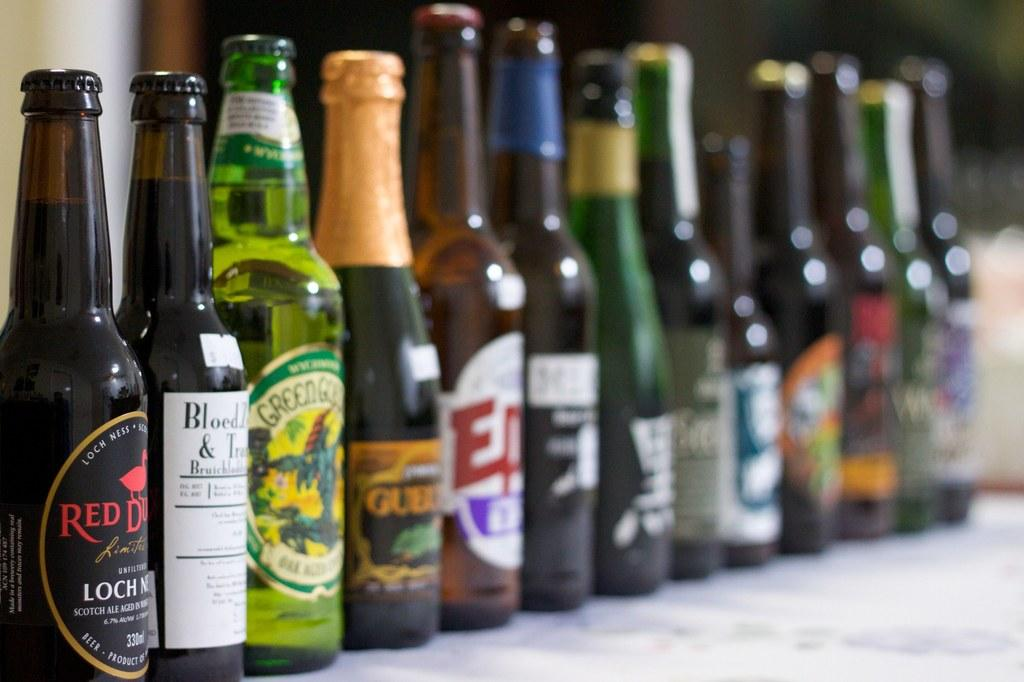<image>
Give a short and clear explanation of the subsequent image. a row of bottles of alcohol with one of them labeled as red duck 